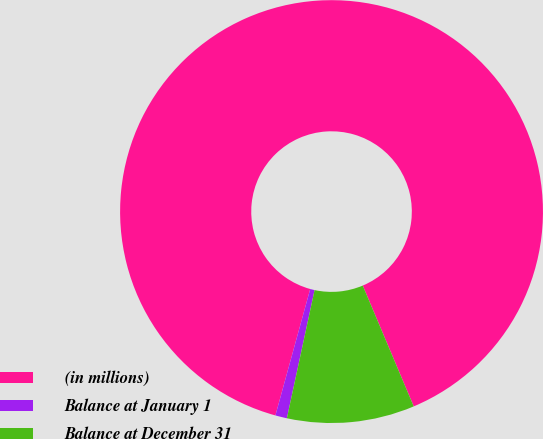<chart> <loc_0><loc_0><loc_500><loc_500><pie_chart><fcel>(in millions)<fcel>Balance at January 1<fcel>Balance at December 31<nl><fcel>89.37%<fcel>0.89%<fcel>9.74%<nl></chart> 